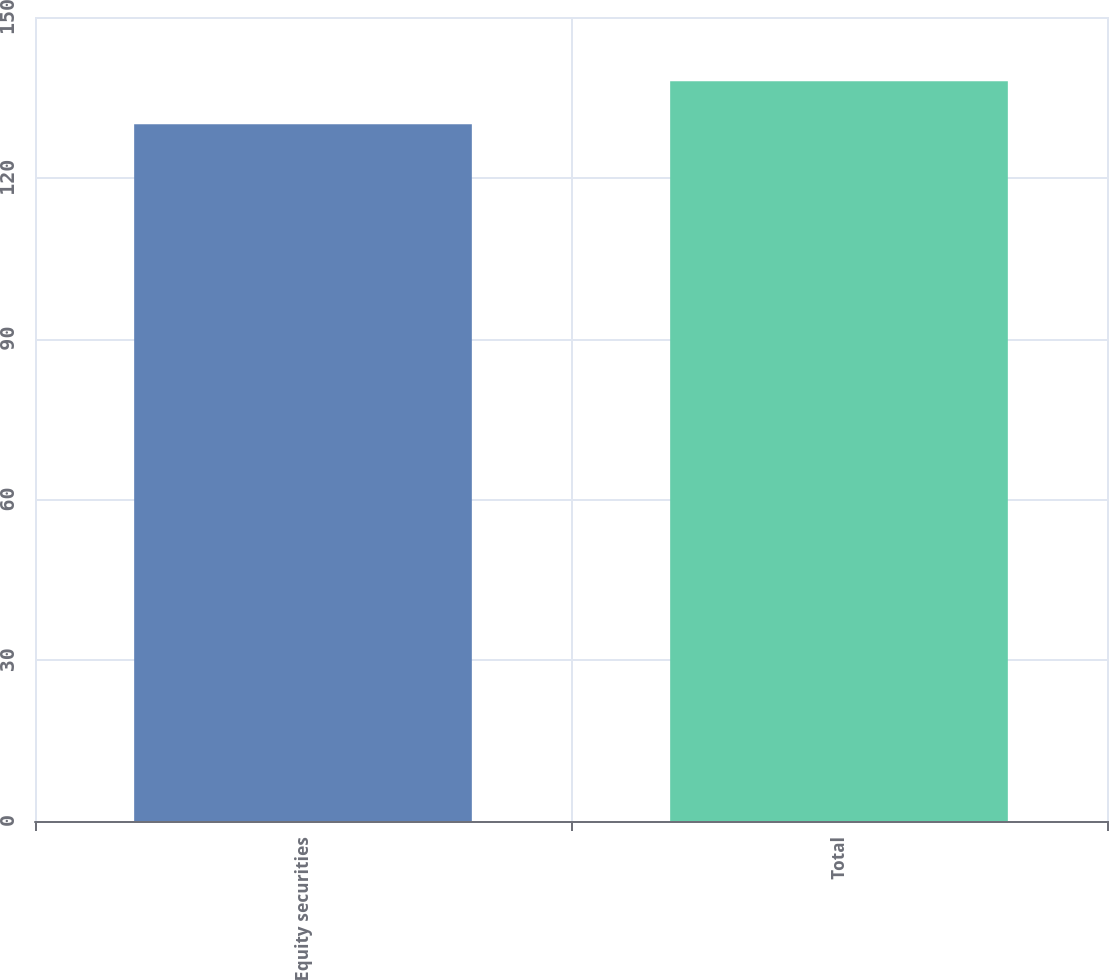Convert chart to OTSL. <chart><loc_0><loc_0><loc_500><loc_500><bar_chart><fcel>Equity securities<fcel>Total<nl><fcel>130<fcel>138<nl></chart> 